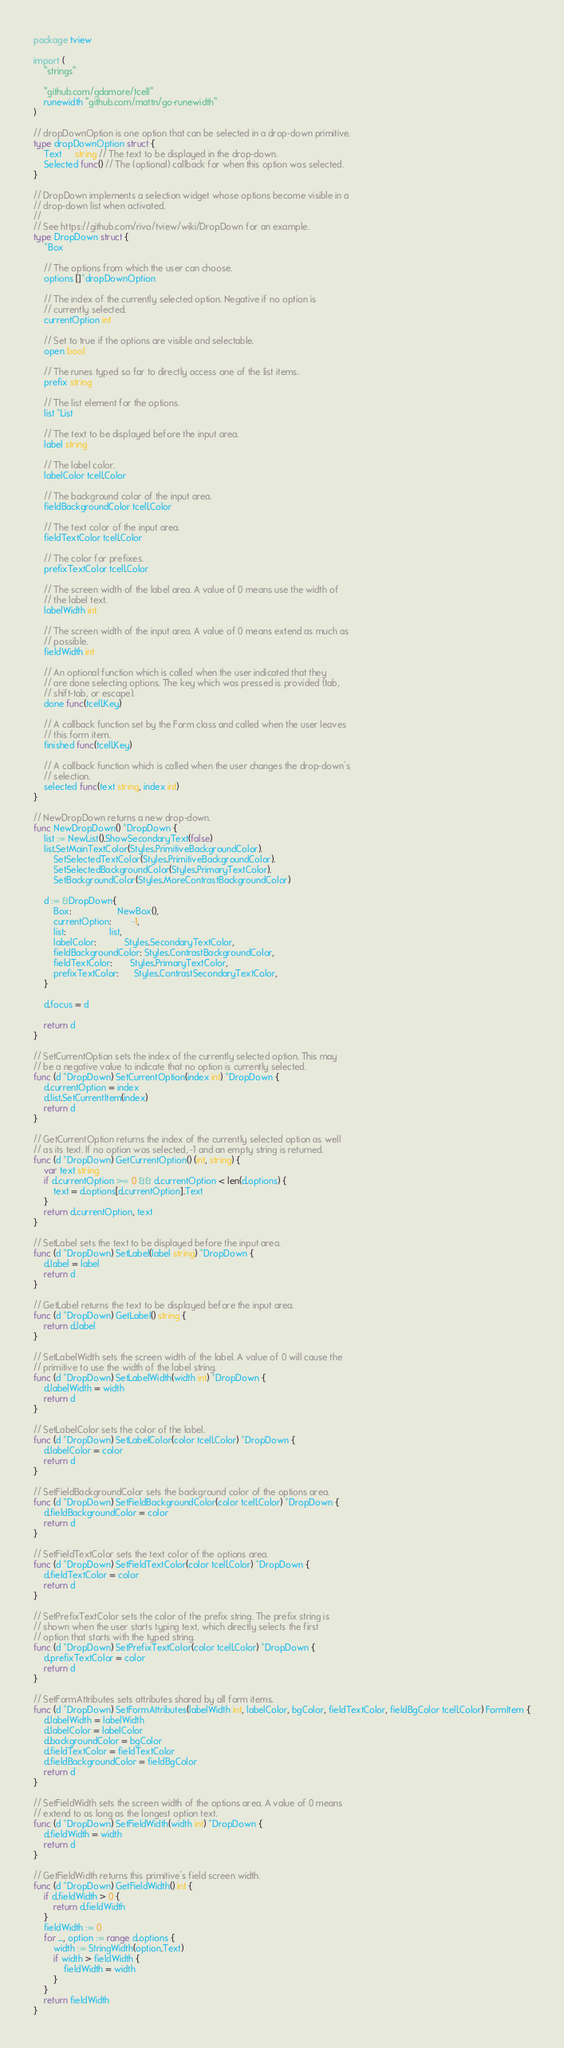Convert code to text. <code><loc_0><loc_0><loc_500><loc_500><_Go_>package tview

import (
	"strings"

	"github.com/gdamore/tcell"
	runewidth "github.com/mattn/go-runewidth"
)

// dropDownOption is one option that can be selected in a drop-down primitive.
type dropDownOption struct {
	Text     string // The text to be displayed in the drop-down.
	Selected func() // The (optional) callback for when this option was selected.
}

// DropDown implements a selection widget whose options become visible in a
// drop-down list when activated.
//
// See https://github.com/rivo/tview/wiki/DropDown for an example.
type DropDown struct {
	*Box

	// The options from which the user can choose.
	options []*dropDownOption

	// The index of the currently selected option. Negative if no option is
	// currently selected.
	currentOption int

	// Set to true if the options are visible and selectable.
	open bool

	// The runes typed so far to directly access one of the list items.
	prefix string

	// The list element for the options.
	list *List

	// The text to be displayed before the input area.
	label string

	// The label color.
	labelColor tcell.Color

	// The background color of the input area.
	fieldBackgroundColor tcell.Color

	// The text color of the input area.
	fieldTextColor tcell.Color

	// The color for prefixes.
	prefixTextColor tcell.Color

	// The screen width of the label area. A value of 0 means use the width of
	// the label text.
	labelWidth int

	// The screen width of the input area. A value of 0 means extend as much as
	// possible.
	fieldWidth int

	// An optional function which is called when the user indicated that they
	// are done selecting options. The key which was pressed is provided (tab,
	// shift-tab, or escape).
	done func(tcell.Key)

	// A callback function set by the Form class and called when the user leaves
	// this form item.
	finished func(tcell.Key)

	// A callback function which is called when the user changes the drop-down's
	// selection.
	selected func(text string, index int)
}

// NewDropDown returns a new drop-down.
func NewDropDown() *DropDown {
	list := NewList().ShowSecondaryText(false)
	list.SetMainTextColor(Styles.PrimitiveBackgroundColor).
		SetSelectedTextColor(Styles.PrimitiveBackgroundColor).
		SetSelectedBackgroundColor(Styles.PrimaryTextColor).
		SetBackgroundColor(Styles.MoreContrastBackgroundColor)

	d := &DropDown{
		Box:                  NewBox(),
		currentOption:        -1,
		list:                 list,
		labelColor:           Styles.SecondaryTextColor,
		fieldBackgroundColor: Styles.ContrastBackgroundColor,
		fieldTextColor:       Styles.PrimaryTextColor,
		prefixTextColor:      Styles.ContrastSecondaryTextColor,
	}

	d.focus = d

	return d
}

// SetCurrentOption sets the index of the currently selected option. This may
// be a negative value to indicate that no option is currently selected.
func (d *DropDown) SetCurrentOption(index int) *DropDown {
	d.currentOption = index
	d.list.SetCurrentItem(index)
	return d
}

// GetCurrentOption returns the index of the currently selected option as well
// as its text. If no option was selected, -1 and an empty string is returned.
func (d *DropDown) GetCurrentOption() (int, string) {
	var text string
	if d.currentOption >= 0 && d.currentOption < len(d.options) {
		text = d.options[d.currentOption].Text
	}
	return d.currentOption, text
}

// SetLabel sets the text to be displayed before the input area.
func (d *DropDown) SetLabel(label string) *DropDown {
	d.label = label
	return d
}

// GetLabel returns the text to be displayed before the input area.
func (d *DropDown) GetLabel() string {
	return d.label
}

// SetLabelWidth sets the screen width of the label. A value of 0 will cause the
// primitive to use the width of the label string.
func (d *DropDown) SetLabelWidth(width int) *DropDown {
	d.labelWidth = width
	return d
}

// SetLabelColor sets the color of the label.
func (d *DropDown) SetLabelColor(color tcell.Color) *DropDown {
	d.labelColor = color
	return d
}

// SetFieldBackgroundColor sets the background color of the options area.
func (d *DropDown) SetFieldBackgroundColor(color tcell.Color) *DropDown {
	d.fieldBackgroundColor = color
	return d
}

// SetFieldTextColor sets the text color of the options area.
func (d *DropDown) SetFieldTextColor(color tcell.Color) *DropDown {
	d.fieldTextColor = color
	return d
}

// SetPrefixTextColor sets the color of the prefix string. The prefix string is
// shown when the user starts typing text, which directly selects the first
// option that starts with the typed string.
func (d *DropDown) SetPrefixTextColor(color tcell.Color) *DropDown {
	d.prefixTextColor = color
	return d
}

// SetFormAttributes sets attributes shared by all form items.
func (d *DropDown) SetFormAttributes(labelWidth int, labelColor, bgColor, fieldTextColor, fieldBgColor tcell.Color) FormItem {
	d.labelWidth = labelWidth
	d.labelColor = labelColor
	d.backgroundColor = bgColor
	d.fieldTextColor = fieldTextColor
	d.fieldBackgroundColor = fieldBgColor
	return d
}

// SetFieldWidth sets the screen width of the options area. A value of 0 means
// extend to as long as the longest option text.
func (d *DropDown) SetFieldWidth(width int) *DropDown {
	d.fieldWidth = width
	return d
}

// GetFieldWidth returns this primitive's field screen width.
func (d *DropDown) GetFieldWidth() int {
	if d.fieldWidth > 0 {
		return d.fieldWidth
	}
	fieldWidth := 0
	for _, option := range d.options {
		width := StringWidth(option.Text)
		if width > fieldWidth {
			fieldWidth = width
		}
	}
	return fieldWidth
}
</code> 